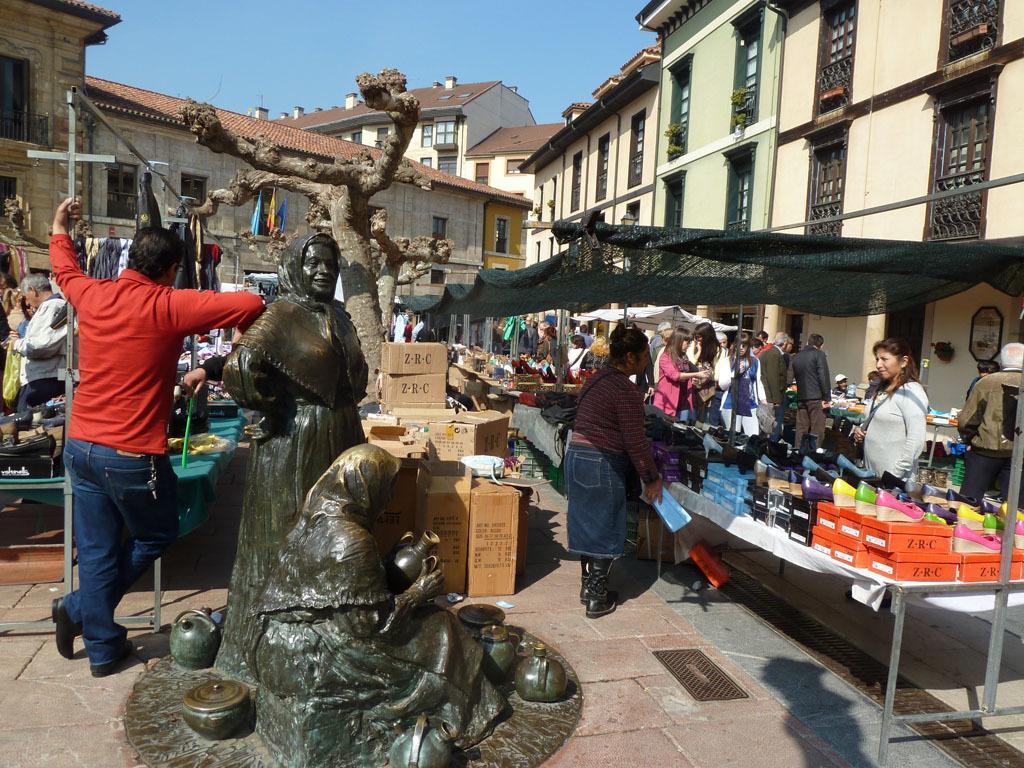Please provide a concise description of this image. In this image we can see the roof houses. We can also see the people, tree, cardboard boxes and also the sculptures. On the right we can see the shelter. We can also see the table and on the table we can see the boxes and also the footwear. We can see the sky and at the bottom we can see the path. 